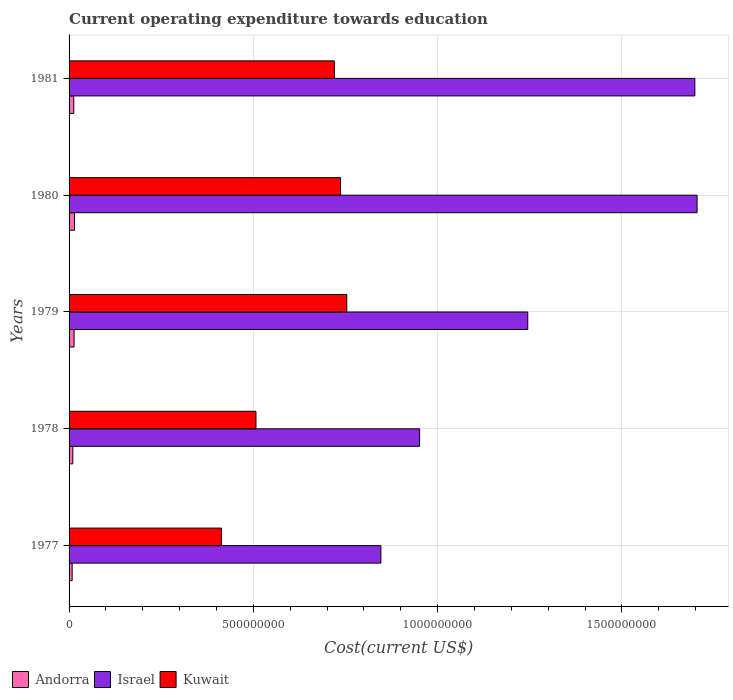Are the number of bars per tick equal to the number of legend labels?
Ensure brevity in your answer.  Yes. What is the label of the 4th group of bars from the top?
Offer a terse response. 1978. In how many cases, is the number of bars for a given year not equal to the number of legend labels?
Your response must be concise. 0. What is the expenditure towards education in Israel in 1980?
Give a very brief answer. 1.70e+09. Across all years, what is the maximum expenditure towards education in Kuwait?
Ensure brevity in your answer.  7.54e+08. Across all years, what is the minimum expenditure towards education in Kuwait?
Your response must be concise. 4.14e+08. In which year was the expenditure towards education in Andorra minimum?
Ensure brevity in your answer.  1977. What is the total expenditure towards education in Andorra in the graph?
Your answer should be compact. 5.97e+07. What is the difference between the expenditure towards education in Israel in 1979 and that in 1981?
Ensure brevity in your answer.  -4.53e+08. What is the difference between the expenditure towards education in Kuwait in 1980 and the expenditure towards education in Israel in 1977?
Provide a short and direct response. -1.09e+08. What is the average expenditure towards education in Kuwait per year?
Make the answer very short. 6.26e+08. In the year 1978, what is the difference between the expenditure towards education in Andorra and expenditure towards education in Israel?
Your answer should be very brief. -9.41e+08. What is the ratio of the expenditure towards education in Andorra in 1980 to that in 1981?
Provide a short and direct response. 1.15. Is the expenditure towards education in Israel in 1977 less than that in 1981?
Make the answer very short. Yes. Is the difference between the expenditure towards education in Andorra in 1978 and 1979 greater than the difference between the expenditure towards education in Israel in 1978 and 1979?
Offer a terse response. Yes. What is the difference between the highest and the second highest expenditure towards education in Kuwait?
Provide a succinct answer. 1.68e+07. What is the difference between the highest and the lowest expenditure towards education in Andorra?
Your response must be concise. 6.35e+06. Is the sum of the expenditure towards education in Kuwait in 1978 and 1981 greater than the maximum expenditure towards education in Israel across all years?
Your answer should be very brief. No. What does the 2nd bar from the top in 1979 represents?
Offer a very short reply. Israel. What does the 3rd bar from the bottom in 1981 represents?
Provide a short and direct response. Kuwait. How many years are there in the graph?
Offer a very short reply. 5. Are the values on the major ticks of X-axis written in scientific E-notation?
Your answer should be very brief. No. Does the graph contain any zero values?
Provide a short and direct response. No. Does the graph contain grids?
Your response must be concise. Yes. Where does the legend appear in the graph?
Your response must be concise. Bottom left. What is the title of the graph?
Your response must be concise. Current operating expenditure towards education. What is the label or title of the X-axis?
Provide a succinct answer. Cost(current US$). What is the Cost(current US$) of Andorra in 1977?
Provide a short and direct response. 8.38e+06. What is the Cost(current US$) in Israel in 1977?
Offer a very short reply. 8.46e+08. What is the Cost(current US$) of Kuwait in 1977?
Provide a succinct answer. 4.14e+08. What is the Cost(current US$) in Andorra in 1978?
Keep it short and to the point. 1.02e+07. What is the Cost(current US$) of Israel in 1978?
Provide a short and direct response. 9.51e+08. What is the Cost(current US$) in Kuwait in 1978?
Your response must be concise. 5.07e+08. What is the Cost(current US$) of Andorra in 1979?
Your response must be concise. 1.36e+07. What is the Cost(current US$) of Israel in 1979?
Keep it short and to the point. 1.24e+09. What is the Cost(current US$) of Kuwait in 1979?
Your answer should be very brief. 7.54e+08. What is the Cost(current US$) in Andorra in 1980?
Ensure brevity in your answer.  1.47e+07. What is the Cost(current US$) in Israel in 1980?
Ensure brevity in your answer.  1.70e+09. What is the Cost(current US$) in Kuwait in 1980?
Your answer should be very brief. 7.37e+08. What is the Cost(current US$) in Andorra in 1981?
Provide a short and direct response. 1.28e+07. What is the Cost(current US$) in Israel in 1981?
Provide a short and direct response. 1.70e+09. What is the Cost(current US$) of Kuwait in 1981?
Your answer should be compact. 7.20e+08. Across all years, what is the maximum Cost(current US$) in Andorra?
Offer a terse response. 1.47e+07. Across all years, what is the maximum Cost(current US$) in Israel?
Ensure brevity in your answer.  1.70e+09. Across all years, what is the maximum Cost(current US$) of Kuwait?
Your answer should be compact. 7.54e+08. Across all years, what is the minimum Cost(current US$) of Andorra?
Your answer should be very brief. 8.38e+06. Across all years, what is the minimum Cost(current US$) in Israel?
Provide a short and direct response. 8.46e+08. Across all years, what is the minimum Cost(current US$) in Kuwait?
Your response must be concise. 4.14e+08. What is the total Cost(current US$) of Andorra in the graph?
Your answer should be compact. 5.97e+07. What is the total Cost(current US$) of Israel in the graph?
Offer a terse response. 6.44e+09. What is the total Cost(current US$) in Kuwait in the graph?
Provide a succinct answer. 3.13e+09. What is the difference between the Cost(current US$) of Andorra in 1977 and that in 1978?
Keep it short and to the point. -1.78e+06. What is the difference between the Cost(current US$) in Israel in 1977 and that in 1978?
Give a very brief answer. -1.05e+08. What is the difference between the Cost(current US$) of Kuwait in 1977 and that in 1978?
Your answer should be compact. -9.36e+07. What is the difference between the Cost(current US$) of Andorra in 1977 and that in 1979?
Your response must be concise. -5.20e+06. What is the difference between the Cost(current US$) of Israel in 1977 and that in 1979?
Your response must be concise. -3.99e+08. What is the difference between the Cost(current US$) of Kuwait in 1977 and that in 1979?
Provide a succinct answer. -3.40e+08. What is the difference between the Cost(current US$) of Andorra in 1977 and that in 1980?
Offer a terse response. -6.35e+06. What is the difference between the Cost(current US$) of Israel in 1977 and that in 1980?
Make the answer very short. -8.58e+08. What is the difference between the Cost(current US$) in Kuwait in 1977 and that in 1980?
Your response must be concise. -3.23e+08. What is the difference between the Cost(current US$) in Andorra in 1977 and that in 1981?
Your response must be concise. -4.45e+06. What is the difference between the Cost(current US$) in Israel in 1977 and that in 1981?
Provide a short and direct response. -8.52e+08. What is the difference between the Cost(current US$) of Kuwait in 1977 and that in 1981?
Your answer should be compact. -3.06e+08. What is the difference between the Cost(current US$) in Andorra in 1978 and that in 1979?
Provide a succinct answer. -3.42e+06. What is the difference between the Cost(current US$) of Israel in 1978 and that in 1979?
Keep it short and to the point. -2.93e+08. What is the difference between the Cost(current US$) of Kuwait in 1978 and that in 1979?
Your response must be concise. -2.46e+08. What is the difference between the Cost(current US$) in Andorra in 1978 and that in 1980?
Make the answer very short. -4.57e+06. What is the difference between the Cost(current US$) in Israel in 1978 and that in 1980?
Keep it short and to the point. -7.53e+08. What is the difference between the Cost(current US$) of Kuwait in 1978 and that in 1980?
Your answer should be very brief. -2.30e+08. What is the difference between the Cost(current US$) in Andorra in 1978 and that in 1981?
Offer a very short reply. -2.67e+06. What is the difference between the Cost(current US$) in Israel in 1978 and that in 1981?
Offer a terse response. -7.47e+08. What is the difference between the Cost(current US$) of Kuwait in 1978 and that in 1981?
Your answer should be compact. -2.13e+08. What is the difference between the Cost(current US$) in Andorra in 1979 and that in 1980?
Provide a succinct answer. -1.15e+06. What is the difference between the Cost(current US$) of Israel in 1979 and that in 1980?
Offer a very short reply. -4.60e+08. What is the difference between the Cost(current US$) in Kuwait in 1979 and that in 1980?
Offer a terse response. 1.68e+07. What is the difference between the Cost(current US$) of Andorra in 1979 and that in 1981?
Make the answer very short. 7.45e+05. What is the difference between the Cost(current US$) of Israel in 1979 and that in 1981?
Your answer should be compact. -4.53e+08. What is the difference between the Cost(current US$) of Kuwait in 1979 and that in 1981?
Keep it short and to the point. 3.36e+07. What is the difference between the Cost(current US$) of Andorra in 1980 and that in 1981?
Keep it short and to the point. 1.89e+06. What is the difference between the Cost(current US$) of Israel in 1980 and that in 1981?
Keep it short and to the point. 6.10e+06. What is the difference between the Cost(current US$) in Kuwait in 1980 and that in 1981?
Your answer should be very brief. 1.68e+07. What is the difference between the Cost(current US$) of Andorra in 1977 and the Cost(current US$) of Israel in 1978?
Keep it short and to the point. -9.43e+08. What is the difference between the Cost(current US$) of Andorra in 1977 and the Cost(current US$) of Kuwait in 1978?
Offer a terse response. -4.99e+08. What is the difference between the Cost(current US$) of Israel in 1977 and the Cost(current US$) of Kuwait in 1978?
Your answer should be compact. 3.39e+08. What is the difference between the Cost(current US$) of Andorra in 1977 and the Cost(current US$) of Israel in 1979?
Provide a succinct answer. -1.24e+09. What is the difference between the Cost(current US$) in Andorra in 1977 and the Cost(current US$) in Kuwait in 1979?
Ensure brevity in your answer.  -7.45e+08. What is the difference between the Cost(current US$) in Israel in 1977 and the Cost(current US$) in Kuwait in 1979?
Offer a terse response. 9.26e+07. What is the difference between the Cost(current US$) in Andorra in 1977 and the Cost(current US$) in Israel in 1980?
Offer a very short reply. -1.70e+09. What is the difference between the Cost(current US$) in Andorra in 1977 and the Cost(current US$) in Kuwait in 1980?
Keep it short and to the point. -7.28e+08. What is the difference between the Cost(current US$) of Israel in 1977 and the Cost(current US$) of Kuwait in 1980?
Offer a terse response. 1.09e+08. What is the difference between the Cost(current US$) of Andorra in 1977 and the Cost(current US$) of Israel in 1981?
Your answer should be compact. -1.69e+09. What is the difference between the Cost(current US$) in Andorra in 1977 and the Cost(current US$) in Kuwait in 1981?
Offer a very short reply. -7.12e+08. What is the difference between the Cost(current US$) in Israel in 1977 and the Cost(current US$) in Kuwait in 1981?
Keep it short and to the point. 1.26e+08. What is the difference between the Cost(current US$) of Andorra in 1978 and the Cost(current US$) of Israel in 1979?
Give a very brief answer. -1.23e+09. What is the difference between the Cost(current US$) in Andorra in 1978 and the Cost(current US$) in Kuwait in 1979?
Your response must be concise. -7.43e+08. What is the difference between the Cost(current US$) in Israel in 1978 and the Cost(current US$) in Kuwait in 1979?
Provide a short and direct response. 1.98e+08. What is the difference between the Cost(current US$) of Andorra in 1978 and the Cost(current US$) of Israel in 1980?
Give a very brief answer. -1.69e+09. What is the difference between the Cost(current US$) of Andorra in 1978 and the Cost(current US$) of Kuwait in 1980?
Provide a short and direct response. -7.27e+08. What is the difference between the Cost(current US$) of Israel in 1978 and the Cost(current US$) of Kuwait in 1980?
Your answer should be compact. 2.15e+08. What is the difference between the Cost(current US$) in Andorra in 1978 and the Cost(current US$) in Israel in 1981?
Provide a succinct answer. -1.69e+09. What is the difference between the Cost(current US$) in Andorra in 1978 and the Cost(current US$) in Kuwait in 1981?
Provide a short and direct response. -7.10e+08. What is the difference between the Cost(current US$) of Israel in 1978 and the Cost(current US$) of Kuwait in 1981?
Ensure brevity in your answer.  2.31e+08. What is the difference between the Cost(current US$) of Andorra in 1979 and the Cost(current US$) of Israel in 1980?
Give a very brief answer. -1.69e+09. What is the difference between the Cost(current US$) of Andorra in 1979 and the Cost(current US$) of Kuwait in 1980?
Keep it short and to the point. -7.23e+08. What is the difference between the Cost(current US$) in Israel in 1979 and the Cost(current US$) in Kuwait in 1980?
Provide a succinct answer. 5.08e+08. What is the difference between the Cost(current US$) in Andorra in 1979 and the Cost(current US$) in Israel in 1981?
Provide a succinct answer. -1.68e+09. What is the difference between the Cost(current US$) in Andorra in 1979 and the Cost(current US$) in Kuwait in 1981?
Make the answer very short. -7.06e+08. What is the difference between the Cost(current US$) of Israel in 1979 and the Cost(current US$) of Kuwait in 1981?
Provide a succinct answer. 5.25e+08. What is the difference between the Cost(current US$) in Andorra in 1980 and the Cost(current US$) in Israel in 1981?
Provide a succinct answer. -1.68e+09. What is the difference between the Cost(current US$) of Andorra in 1980 and the Cost(current US$) of Kuwait in 1981?
Make the answer very short. -7.05e+08. What is the difference between the Cost(current US$) in Israel in 1980 and the Cost(current US$) in Kuwait in 1981?
Keep it short and to the point. 9.84e+08. What is the average Cost(current US$) in Andorra per year?
Your answer should be compact. 1.19e+07. What is the average Cost(current US$) in Israel per year?
Make the answer very short. 1.29e+09. What is the average Cost(current US$) in Kuwait per year?
Offer a terse response. 6.26e+08. In the year 1977, what is the difference between the Cost(current US$) of Andorra and Cost(current US$) of Israel?
Provide a succinct answer. -8.38e+08. In the year 1977, what is the difference between the Cost(current US$) of Andorra and Cost(current US$) of Kuwait?
Make the answer very short. -4.05e+08. In the year 1977, what is the difference between the Cost(current US$) of Israel and Cost(current US$) of Kuwait?
Keep it short and to the point. 4.33e+08. In the year 1978, what is the difference between the Cost(current US$) in Andorra and Cost(current US$) in Israel?
Offer a terse response. -9.41e+08. In the year 1978, what is the difference between the Cost(current US$) in Andorra and Cost(current US$) in Kuwait?
Offer a terse response. -4.97e+08. In the year 1978, what is the difference between the Cost(current US$) of Israel and Cost(current US$) of Kuwait?
Make the answer very short. 4.44e+08. In the year 1979, what is the difference between the Cost(current US$) of Andorra and Cost(current US$) of Israel?
Your answer should be very brief. -1.23e+09. In the year 1979, what is the difference between the Cost(current US$) in Andorra and Cost(current US$) in Kuwait?
Keep it short and to the point. -7.40e+08. In the year 1979, what is the difference between the Cost(current US$) of Israel and Cost(current US$) of Kuwait?
Give a very brief answer. 4.91e+08. In the year 1980, what is the difference between the Cost(current US$) in Andorra and Cost(current US$) in Israel?
Your answer should be very brief. -1.69e+09. In the year 1980, what is the difference between the Cost(current US$) in Andorra and Cost(current US$) in Kuwait?
Ensure brevity in your answer.  -7.22e+08. In the year 1980, what is the difference between the Cost(current US$) in Israel and Cost(current US$) in Kuwait?
Offer a very short reply. 9.67e+08. In the year 1981, what is the difference between the Cost(current US$) in Andorra and Cost(current US$) in Israel?
Offer a terse response. -1.69e+09. In the year 1981, what is the difference between the Cost(current US$) in Andorra and Cost(current US$) in Kuwait?
Your answer should be compact. -7.07e+08. In the year 1981, what is the difference between the Cost(current US$) of Israel and Cost(current US$) of Kuwait?
Make the answer very short. 9.78e+08. What is the ratio of the Cost(current US$) in Andorra in 1977 to that in 1978?
Keep it short and to the point. 0.82. What is the ratio of the Cost(current US$) in Israel in 1977 to that in 1978?
Offer a terse response. 0.89. What is the ratio of the Cost(current US$) of Kuwait in 1977 to that in 1978?
Ensure brevity in your answer.  0.82. What is the ratio of the Cost(current US$) in Andorra in 1977 to that in 1979?
Your response must be concise. 0.62. What is the ratio of the Cost(current US$) of Israel in 1977 to that in 1979?
Provide a succinct answer. 0.68. What is the ratio of the Cost(current US$) of Kuwait in 1977 to that in 1979?
Provide a short and direct response. 0.55. What is the ratio of the Cost(current US$) of Andorra in 1977 to that in 1980?
Offer a very short reply. 0.57. What is the ratio of the Cost(current US$) in Israel in 1977 to that in 1980?
Your answer should be compact. 0.5. What is the ratio of the Cost(current US$) in Kuwait in 1977 to that in 1980?
Your answer should be very brief. 0.56. What is the ratio of the Cost(current US$) in Andorra in 1977 to that in 1981?
Offer a terse response. 0.65. What is the ratio of the Cost(current US$) in Israel in 1977 to that in 1981?
Make the answer very short. 0.5. What is the ratio of the Cost(current US$) in Kuwait in 1977 to that in 1981?
Offer a very short reply. 0.57. What is the ratio of the Cost(current US$) in Andorra in 1978 to that in 1979?
Provide a succinct answer. 0.75. What is the ratio of the Cost(current US$) of Israel in 1978 to that in 1979?
Make the answer very short. 0.76. What is the ratio of the Cost(current US$) in Kuwait in 1978 to that in 1979?
Make the answer very short. 0.67. What is the ratio of the Cost(current US$) of Andorra in 1978 to that in 1980?
Offer a very short reply. 0.69. What is the ratio of the Cost(current US$) of Israel in 1978 to that in 1980?
Your answer should be compact. 0.56. What is the ratio of the Cost(current US$) of Kuwait in 1978 to that in 1980?
Keep it short and to the point. 0.69. What is the ratio of the Cost(current US$) of Andorra in 1978 to that in 1981?
Provide a succinct answer. 0.79. What is the ratio of the Cost(current US$) in Israel in 1978 to that in 1981?
Keep it short and to the point. 0.56. What is the ratio of the Cost(current US$) in Kuwait in 1978 to that in 1981?
Offer a very short reply. 0.7. What is the ratio of the Cost(current US$) of Andorra in 1979 to that in 1980?
Your response must be concise. 0.92. What is the ratio of the Cost(current US$) of Israel in 1979 to that in 1980?
Your answer should be very brief. 0.73. What is the ratio of the Cost(current US$) in Kuwait in 1979 to that in 1980?
Offer a very short reply. 1.02. What is the ratio of the Cost(current US$) in Andorra in 1979 to that in 1981?
Make the answer very short. 1.06. What is the ratio of the Cost(current US$) in Israel in 1979 to that in 1981?
Offer a terse response. 0.73. What is the ratio of the Cost(current US$) in Kuwait in 1979 to that in 1981?
Give a very brief answer. 1.05. What is the ratio of the Cost(current US$) of Andorra in 1980 to that in 1981?
Make the answer very short. 1.15. What is the ratio of the Cost(current US$) of Kuwait in 1980 to that in 1981?
Your answer should be very brief. 1.02. What is the difference between the highest and the second highest Cost(current US$) of Andorra?
Provide a short and direct response. 1.15e+06. What is the difference between the highest and the second highest Cost(current US$) of Israel?
Your answer should be very brief. 6.10e+06. What is the difference between the highest and the second highest Cost(current US$) in Kuwait?
Your answer should be compact. 1.68e+07. What is the difference between the highest and the lowest Cost(current US$) in Andorra?
Your answer should be compact. 6.35e+06. What is the difference between the highest and the lowest Cost(current US$) of Israel?
Make the answer very short. 8.58e+08. What is the difference between the highest and the lowest Cost(current US$) of Kuwait?
Your response must be concise. 3.40e+08. 